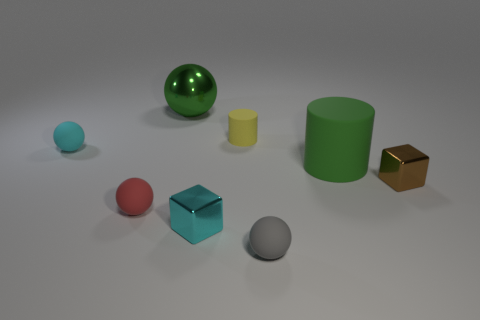What number of rubber objects are both in front of the small cyan shiny cube and behind the small cyan metal block?
Make the answer very short. 0. Are there more red rubber spheres that are in front of the yellow matte cylinder than large cylinders that are to the right of the brown cube?
Your answer should be very brief. Yes. The green rubber cylinder has what size?
Ensure brevity in your answer.  Large. Are there any other matte things of the same shape as the green matte object?
Provide a short and direct response. Yes. Does the green shiny object have the same shape as the tiny rubber object in front of the red rubber thing?
Provide a succinct answer. Yes. There is a ball that is both behind the big green cylinder and left of the big green metal sphere; what size is it?
Provide a succinct answer. Small. What number of shiny objects are there?
Offer a terse response. 3. What material is the green cylinder that is the same size as the green metal thing?
Your answer should be very brief. Rubber. Are there any cyan metallic objects that have the same size as the gray matte ball?
Give a very brief answer. Yes. There is a small metal cube in front of the brown metallic block; does it have the same color as the small matte thing that is to the left of the tiny red matte ball?
Offer a very short reply. Yes. 